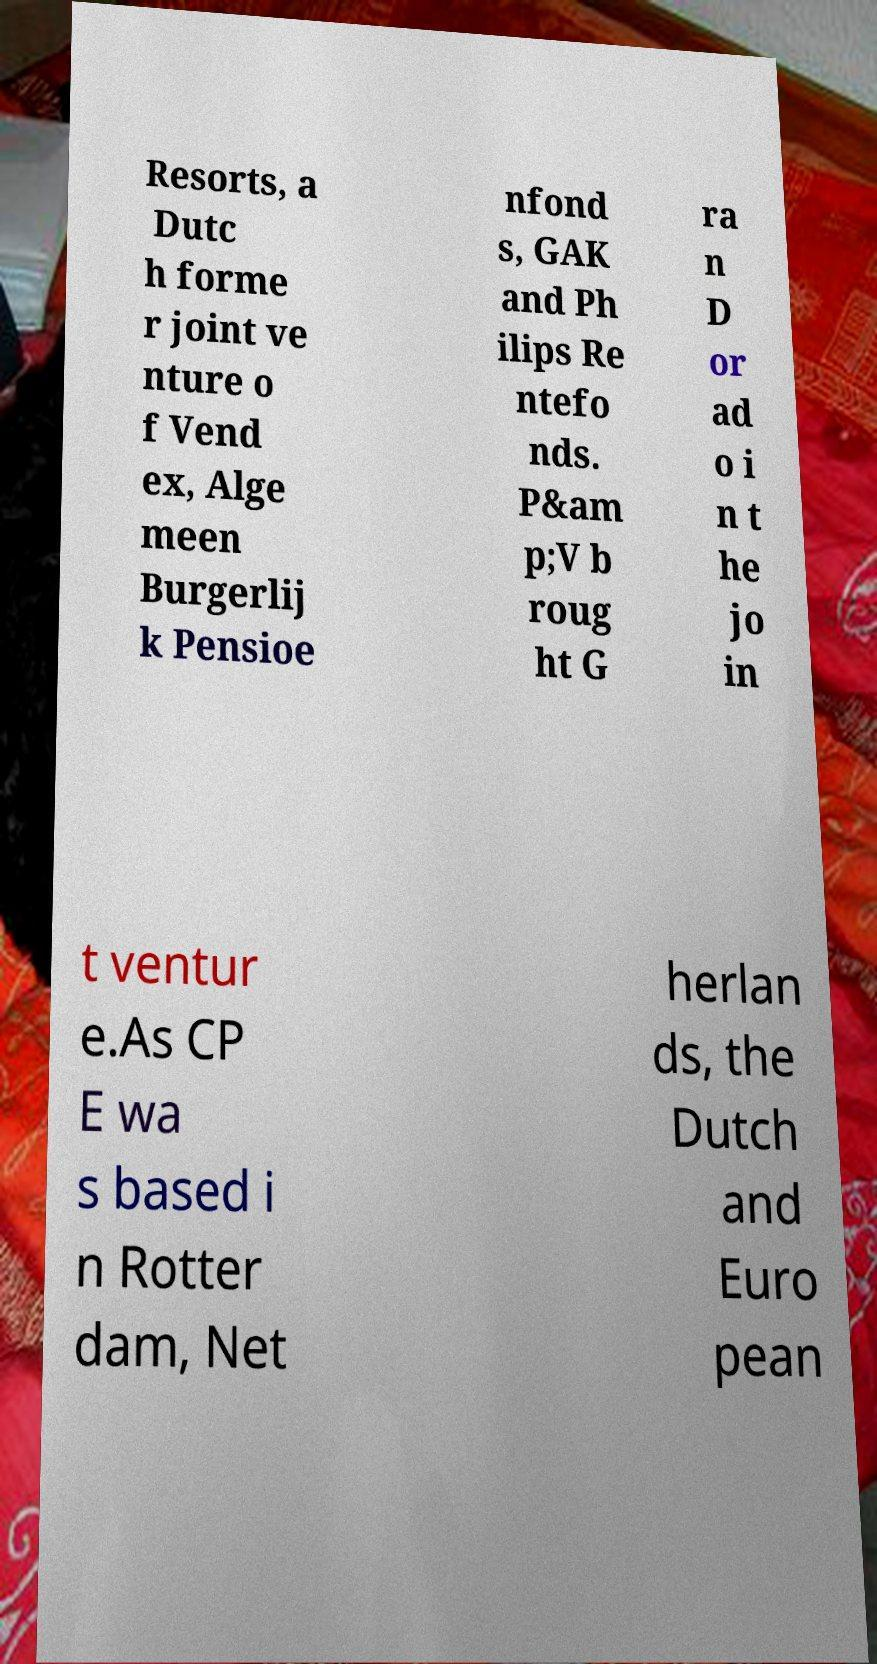Please identify and transcribe the text found in this image. Resorts, a Dutc h forme r joint ve nture o f Vend ex, Alge meen Burgerlij k Pensioe nfond s, GAK and Ph ilips Re ntefo nds. P&am p;V b roug ht G ra n D or ad o i n t he jo in t ventur e.As CP E wa s based i n Rotter dam, Net herlan ds, the Dutch and Euro pean 